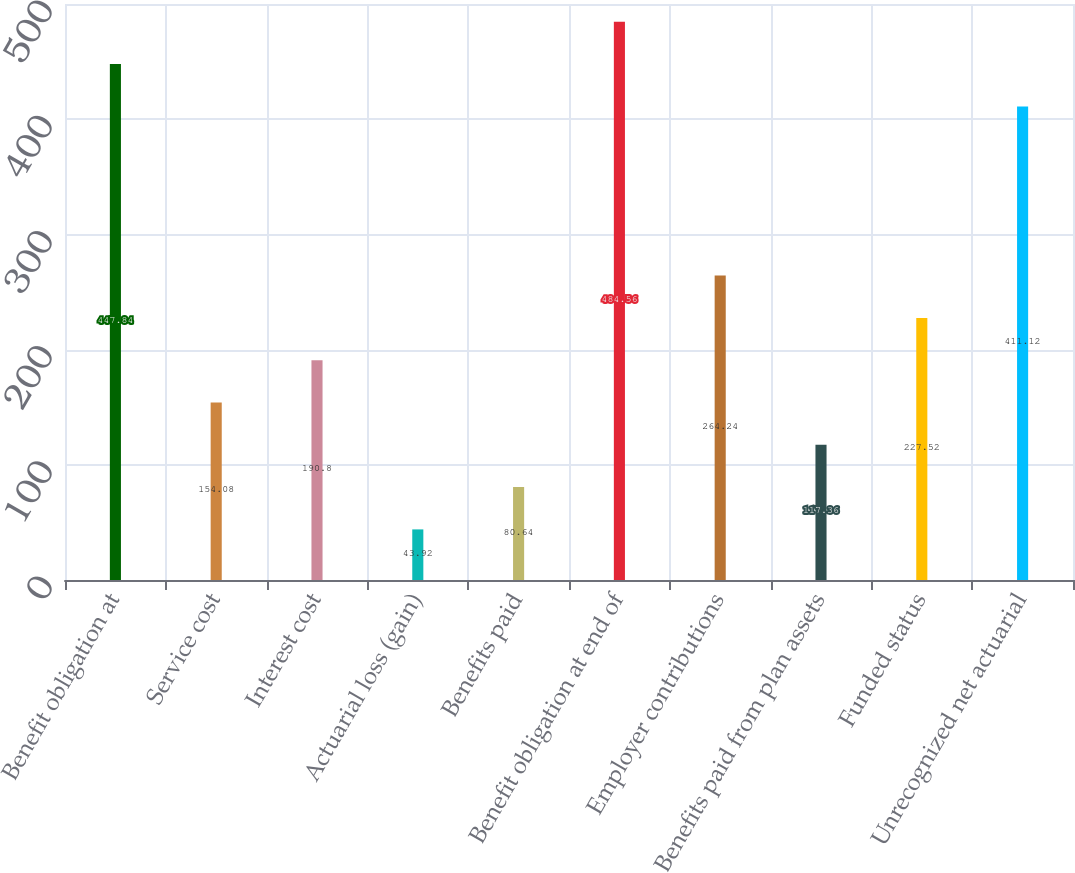<chart> <loc_0><loc_0><loc_500><loc_500><bar_chart><fcel>Benefit obligation at<fcel>Service cost<fcel>Interest cost<fcel>Actuarial loss (gain)<fcel>Benefits paid<fcel>Benefit obligation at end of<fcel>Employer contributions<fcel>Benefits paid from plan assets<fcel>Funded status<fcel>Unrecognized net actuarial<nl><fcel>447.84<fcel>154.08<fcel>190.8<fcel>43.92<fcel>80.64<fcel>484.56<fcel>264.24<fcel>117.36<fcel>227.52<fcel>411.12<nl></chart> 